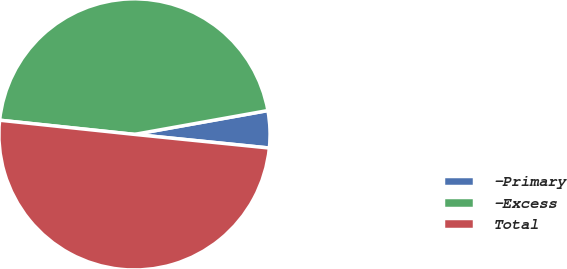<chart> <loc_0><loc_0><loc_500><loc_500><pie_chart><fcel>-Primary<fcel>-Excess<fcel>Total<nl><fcel>4.42%<fcel>45.51%<fcel>50.06%<nl></chart> 